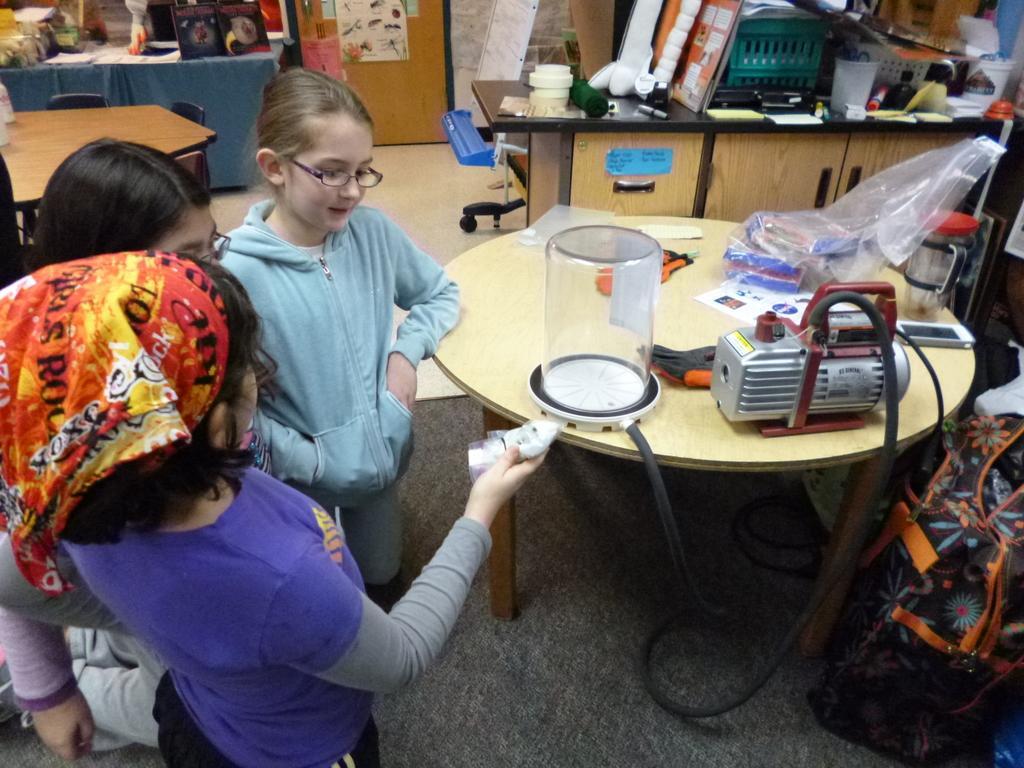Can you describe this image briefly? Here we can see that a group of children sitting on the floor, and in front here is the table, and some objects on it ,and here is the dining table. 